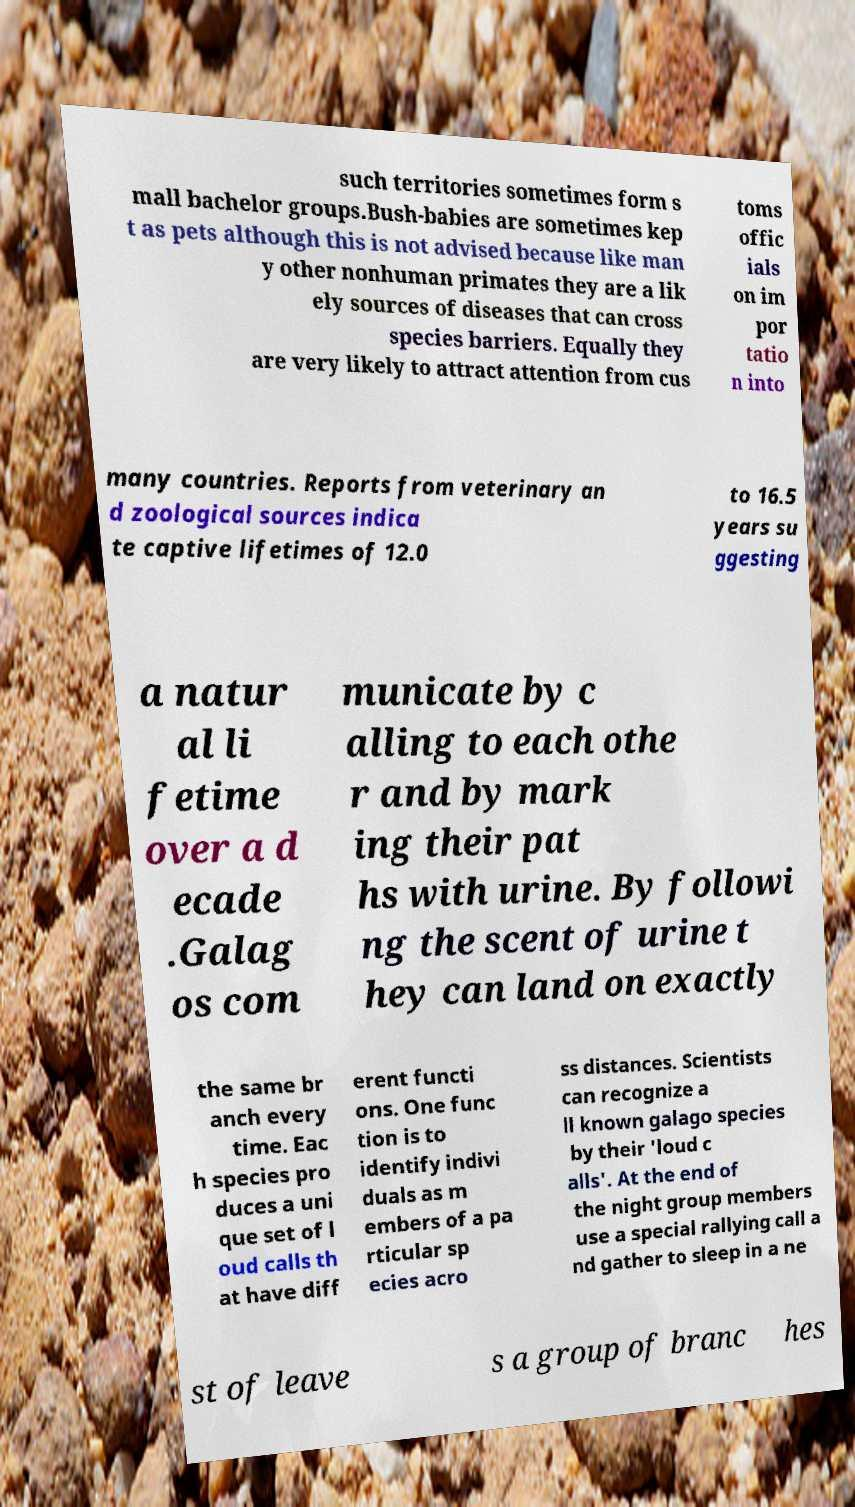Can you accurately transcribe the text from the provided image for me? such territories sometimes form s mall bachelor groups.Bush-babies are sometimes kep t as pets although this is not advised because like man y other nonhuman primates they are a lik ely sources of diseases that can cross species barriers. Equally they are very likely to attract attention from cus toms offic ials on im por tatio n into many countries. Reports from veterinary an d zoological sources indica te captive lifetimes of 12.0 to 16.5 years su ggesting a natur al li fetime over a d ecade .Galag os com municate by c alling to each othe r and by mark ing their pat hs with urine. By followi ng the scent of urine t hey can land on exactly the same br anch every time. Eac h species pro duces a uni que set of l oud calls th at have diff erent functi ons. One func tion is to identify indivi duals as m embers of a pa rticular sp ecies acro ss distances. Scientists can recognize a ll known galago species by their 'loud c alls'. At the end of the night group members use a special rallying call a nd gather to sleep in a ne st of leave s a group of branc hes 